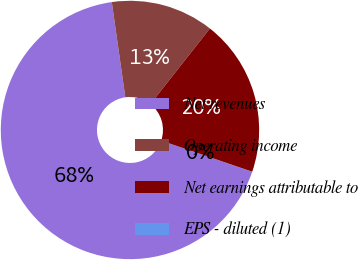Convert chart to OTSL. <chart><loc_0><loc_0><loc_500><loc_500><pie_chart><fcel>Net revenues<fcel>Operating income<fcel>Net earnings attributable to<fcel>EPS - diluted (1)<nl><fcel>67.51%<fcel>12.87%<fcel>19.62%<fcel>0.01%<nl></chart> 